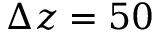<formula> <loc_0><loc_0><loc_500><loc_500>\Delta z = 5 0</formula> 